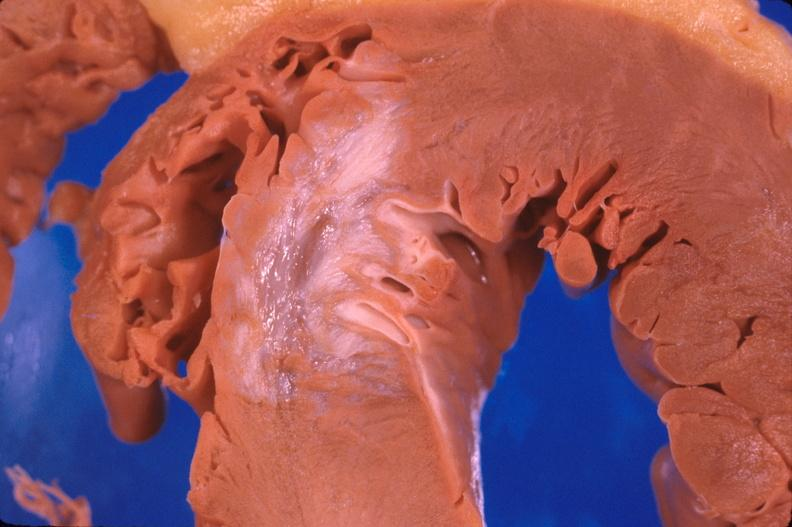does this image show heart, old myocardial infarction with fibrosis?
Answer the question using a single word or phrase. Yes 